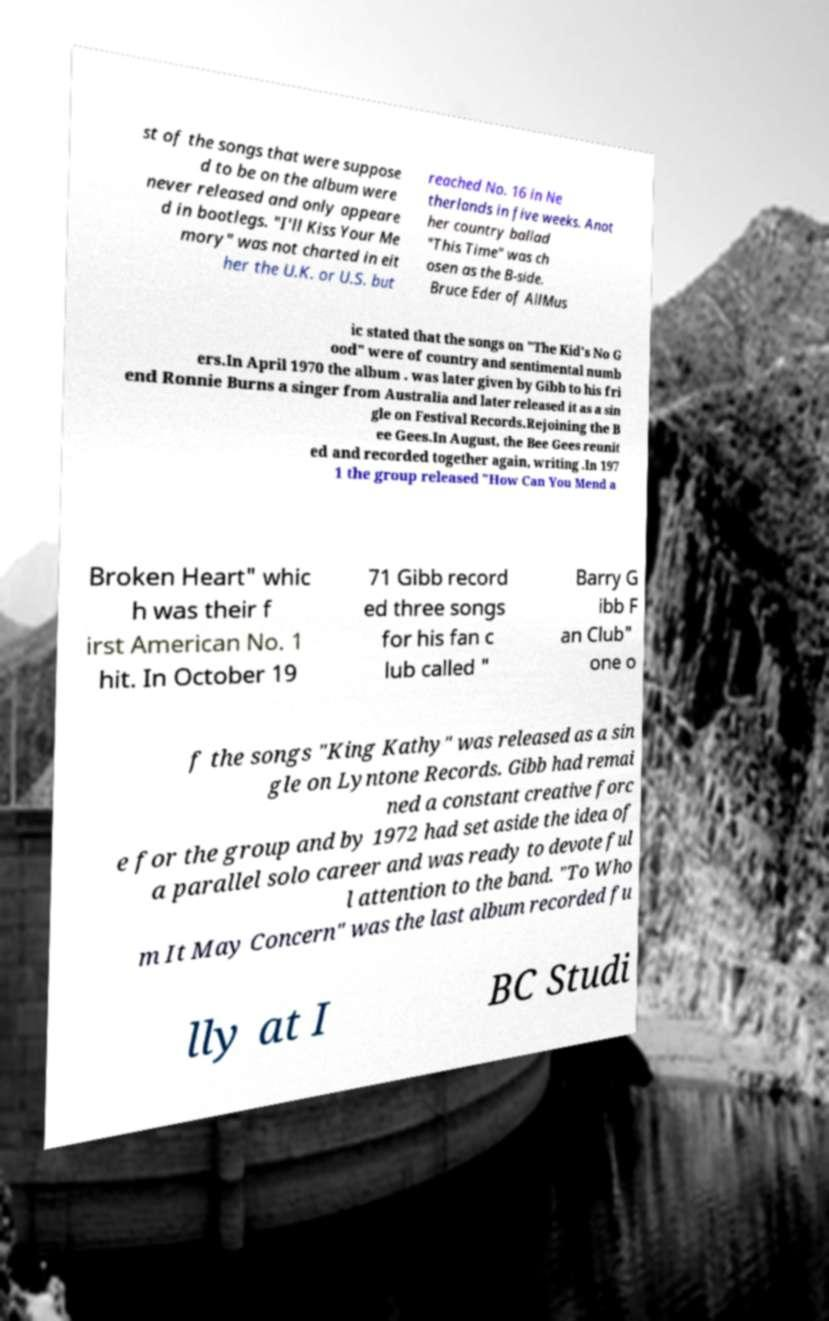For documentation purposes, I need the text within this image transcribed. Could you provide that? st of the songs that were suppose d to be on the album were never released and only appeare d in bootlegs. "I'll Kiss Your Me mory" was not charted in eit her the U.K. or U.S. but reached No. 16 in Ne therlands in five weeks. Anot her country ballad "This Time" was ch osen as the B-side. Bruce Eder of AllMus ic stated that the songs on "The Kid's No G ood" were of country and sentimental numb ers.In April 1970 the album . was later given by Gibb to his fri end Ronnie Burns a singer from Australia and later released it as a sin gle on Festival Records.Rejoining the B ee Gees.In August, the Bee Gees reunit ed and recorded together again, writing .In 197 1 the group released "How Can You Mend a Broken Heart" whic h was their f irst American No. 1 hit. In October 19 71 Gibb record ed three songs for his fan c lub called " Barry G ibb F an Club" one o f the songs "King Kathy" was released as a sin gle on Lyntone Records. Gibb had remai ned a constant creative forc e for the group and by 1972 had set aside the idea of a parallel solo career and was ready to devote ful l attention to the band. "To Who m It May Concern" was the last album recorded fu lly at I BC Studi 